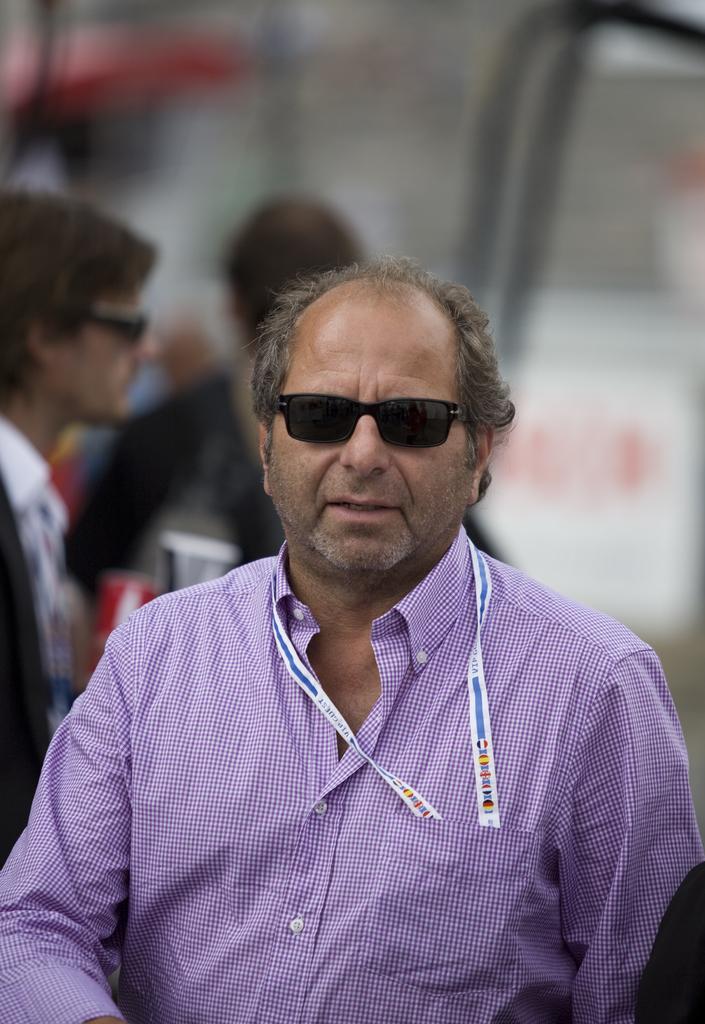In one or two sentences, can you explain what this image depicts? This image consists of a man wearing blue shirt. He is also wearing black shades. In the background, there are many people. The background is blurred. 